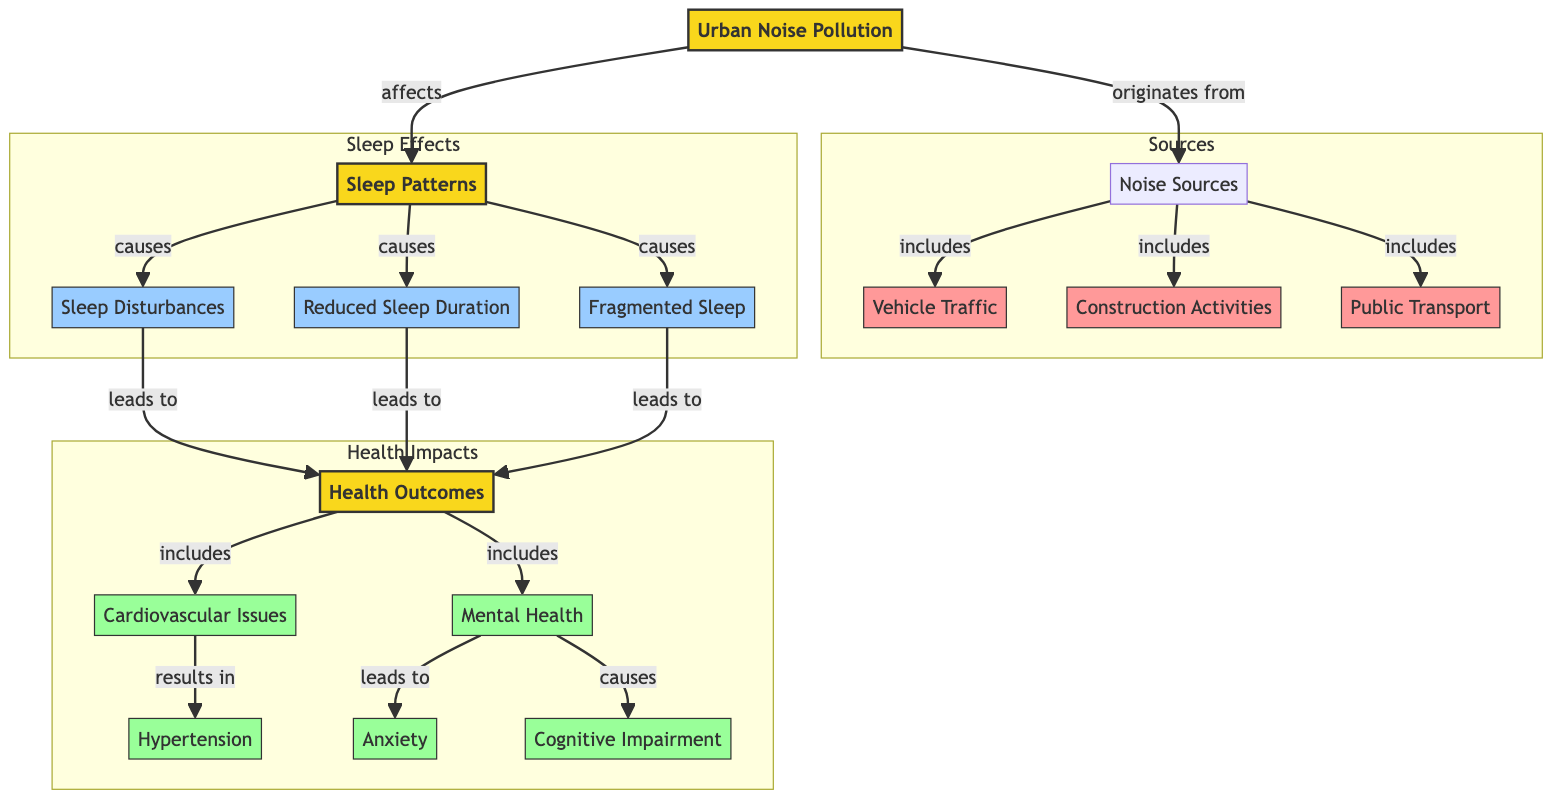What is the main node representing the environmental factor in the diagram? The main node representing the environmental factor in the diagram is "Urban Noise Pollution." It is the central theme illustrated in the diagram from which various connections to other nodes originate.
Answer: Urban Noise Pollution How many sources of noise are identified in the diagram? The diagram identifies four sources of noise: Vehicle Traffic, Construction Activities, Public Transport, and Noise Sources (which encapsulates these three). Counting these sources yields a total of three distinct noise sources.
Answer: 3 Which health outcome is connected to cardiovascular issues? The health outcome connected to cardiovascular issues is "Hypertension," which is indicated as a result of cardiovascular issues following the flow of effects in the diagram.
Answer: Hypertension What three effects are attributed to altered sleep patterns? The three effects attributed to altered sleep patterns are "Sleep Disturbances," "Reduced Sleep Duration," and "Fragmented Sleep." These are all direct effects that arise from the impact of urban noise pollution on sleep patterns.
Answer: Sleep Disturbances, Reduced Sleep Duration, Fragmented Sleep Which health outcome is commonly linked to mental health issues? The health outcome commonly linked to mental health issues is "Anxiety." The diagram shows that mental health leads to anxiety as part of the chain of health impacts stemming from sleep disturbances caused by urban noise pollution.
Answer: Anxiety How does urban noise pollution affect health outcomes indirectly? Urban noise pollution affects health outcomes indirectly by first influencing sleep patterns which then lead to sleep disturbances, reduced sleep duration, and fragmented sleep. This cascading effect ultimately results in several health outcomes, such as cardiovascular issues and mental health conditions.
Answer: Through sleep patterns What is the relationship between reduced sleep duration and health outcomes? The relationship is that reduced sleep duration leads directly to various health outcomes. Specifically, the diagram shows that reduced sleep duration, as one of the effects of sleep patterns, results in negative health impacts.
Answer: Leads to health outcomes Which factor contributes to both sleep disturbances and reduced sleep duration? The factor that contributes to both sleep disturbances and reduced sleep duration is the "Sleep Patterns." This is a central node in the diagram that affects both outcomes as a result of urban noise pollution.
Answer: Sleep Patterns How do cognitive impairments relate to mental health outcomes? Cognitive impairments relate to mental health outcomes as an effect stemming from those mental health issues. The diagram indicates that mental health issues can cause cognitive impairment through a direct line of effect, illustrating a connection between the two.
Answer: Leads to cognitive impairment 